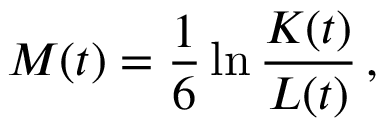Convert formula to latex. <formula><loc_0><loc_0><loc_500><loc_500>M ( t ) = \frac { 1 } { 6 } \ln \frac { K ( t ) } { L ( t ) } \, ,</formula> 